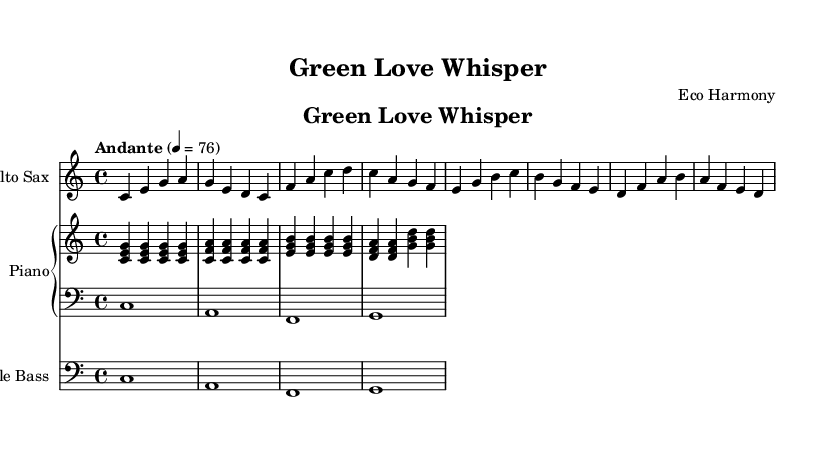What is the key signature of this music? The key signature is indicated at the beginning of the score, showing there are no sharps or flats, which signifies it is in C major.
Answer: C major What is the time signature of this piece? The time signature is located at the beginning of the score. It is represented as a fraction, showing 4 beats in a measure with the quarter note getting the beat, which is expressed as 4/4.
Answer: 4/4 What is the tempo marking for this piece? The tempo marking is written with the Italian word "Andante," followed by a metronome marking (4 = 76) indicating the speed of the music. "Andante" typically suggests a slow, walking pace.
Answer: Andante 4 = 76 How many measures are there in total? Counting the measures from the saxophone, piano (right and left hands), and bass, there are a total of 8 measures represented in the score.
Answer: 8 What instruments are featured in this piece? The score lists three instruments: Alto Saxophone, Piano (with two staves for right and left hands), and Double Bass, specified at the beginning of each staff.
Answer: Alto Saxophone, Piano, Double Bass What themes are suggested by the melody and harmony of this composition? The melodic lines and harmonic progressions create a romantic and soothing atmosphere, reflecting themes of love and nature that align with environmental stewardship. This can be deduced from the soft jazz style and gentle progression.
Answer: Love and environmental stewardship 